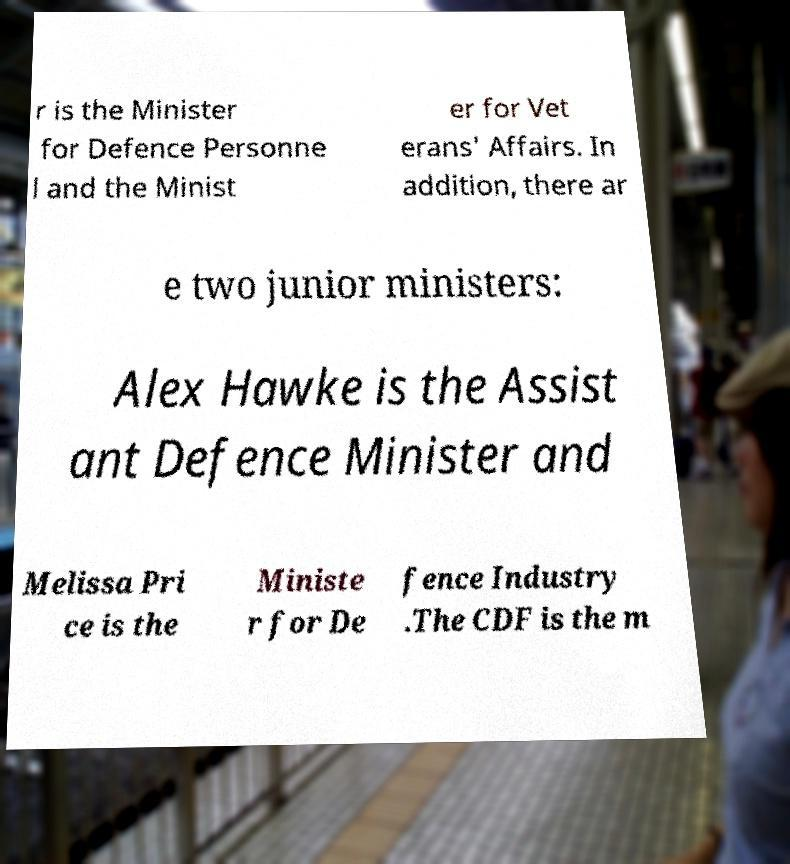Please identify and transcribe the text found in this image. r is the Minister for Defence Personne l and the Minist er for Vet erans' Affairs. In addition, there ar e two junior ministers: Alex Hawke is the Assist ant Defence Minister and Melissa Pri ce is the Ministe r for De fence Industry .The CDF is the m 